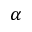<formula> <loc_0><loc_0><loc_500><loc_500>\alpha</formula> 